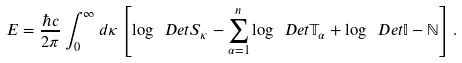<formula> <loc_0><loc_0><loc_500><loc_500>E = \frac { \hbar { c } } { 2 \pi } \int _ { 0 } ^ { \infty } d \kappa \left [ \log \ D e t { S _ { \kappa } } - \sum _ { \alpha = 1 } ^ { n } \log \ D e t { \mathbb { T } _ { \alpha } } + \log \ D e t { \mathbb { I } - \mathbb { N } } \right ] .</formula> 